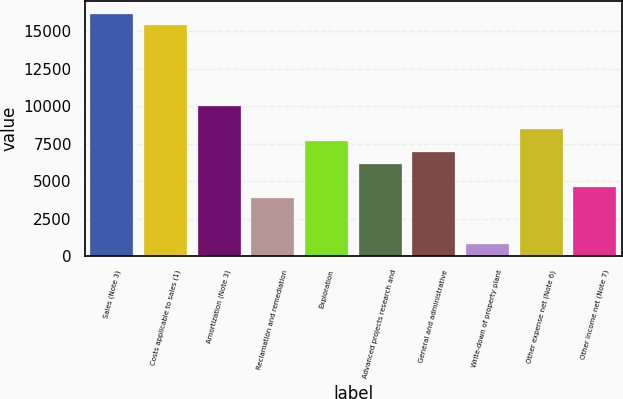Convert chart to OTSL. <chart><loc_0><loc_0><loc_500><loc_500><bar_chart><fcel>Sales (Note 3)<fcel>Costs applicable to sales (1)<fcel>Amortization (Note 3)<fcel>Reclamation and remediation<fcel>Exploration<fcel>Advanced projects research and<fcel>General and administrative<fcel>Write-down of property plant<fcel>Other expense net (Note 6)<fcel>Other income net (Note 7)<nl><fcel>16180.1<fcel>15409.6<fcel>10016.4<fcel>3852.7<fcel>7705<fcel>6164.08<fcel>6934.54<fcel>770.86<fcel>8475.46<fcel>4623.16<nl></chart> 